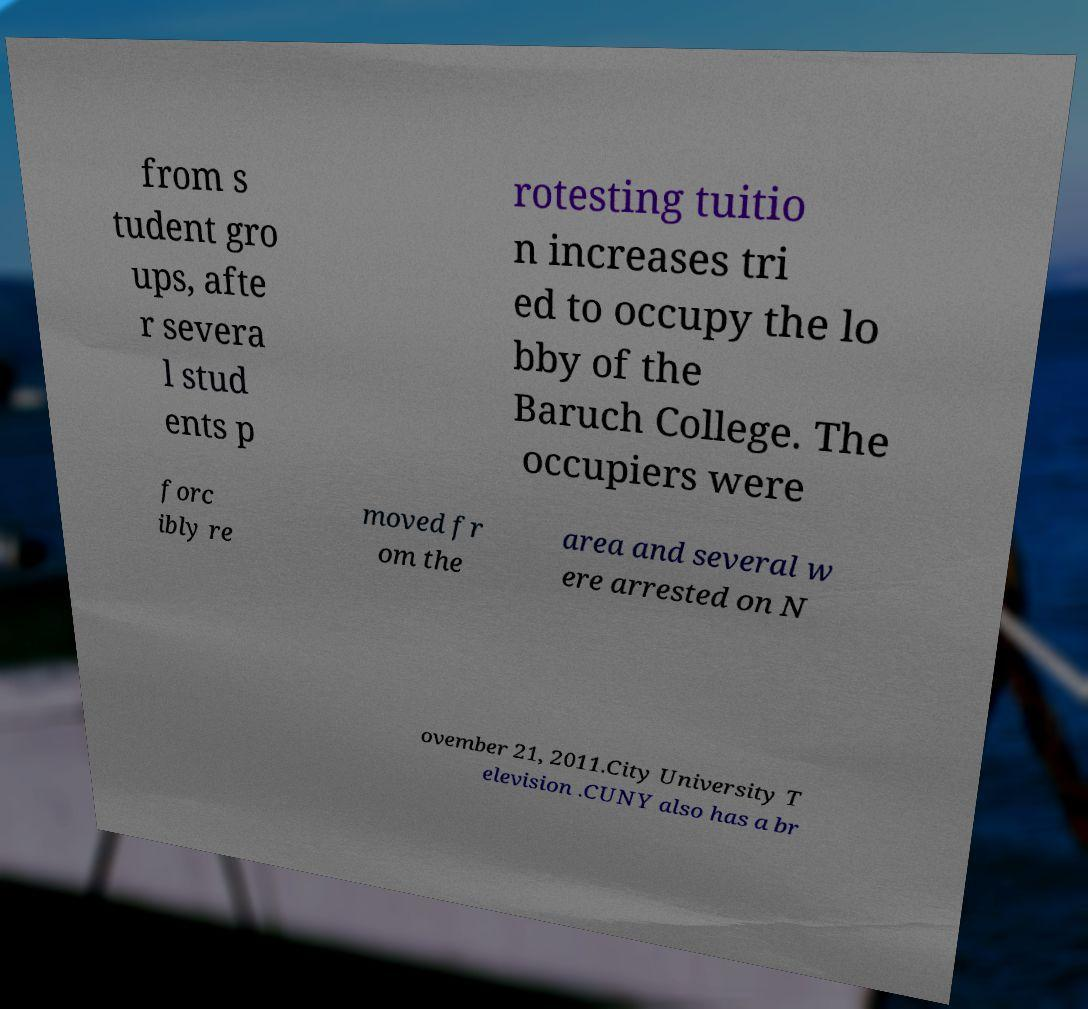Can you read and provide the text displayed in the image?This photo seems to have some interesting text. Can you extract and type it out for me? from s tudent gro ups, afte r severa l stud ents p rotesting tuitio n increases tri ed to occupy the lo bby of the Baruch College. The occupiers were forc ibly re moved fr om the area and several w ere arrested on N ovember 21, 2011.City University T elevision .CUNY also has a br 